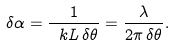<formula> <loc_0><loc_0><loc_500><loc_500>\delta \alpha = \frac { 1 } { \ k L \, \delta \theta } = \frac { \lambda } { 2 \pi \, \delta \theta } .</formula> 